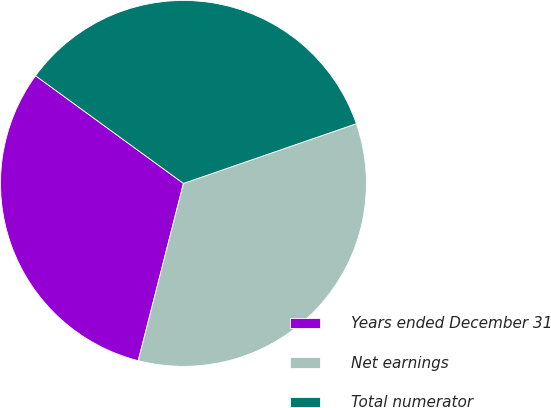Convert chart. <chart><loc_0><loc_0><loc_500><loc_500><pie_chart><fcel>Years ended December 31<fcel>Net earnings<fcel>Total numerator<nl><fcel>31.04%<fcel>34.27%<fcel>34.69%<nl></chart> 